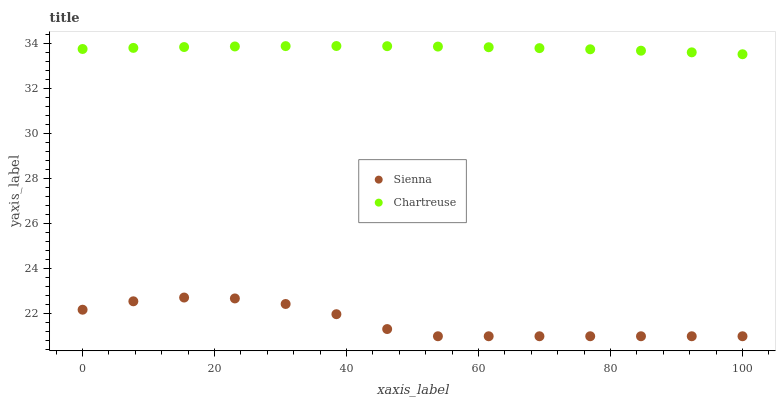Does Sienna have the minimum area under the curve?
Answer yes or no. Yes. Does Chartreuse have the maximum area under the curve?
Answer yes or no. Yes. Does Chartreuse have the minimum area under the curve?
Answer yes or no. No. Is Chartreuse the smoothest?
Answer yes or no. Yes. Is Sienna the roughest?
Answer yes or no. Yes. Is Chartreuse the roughest?
Answer yes or no. No. Does Sienna have the lowest value?
Answer yes or no. Yes. Does Chartreuse have the lowest value?
Answer yes or no. No. Does Chartreuse have the highest value?
Answer yes or no. Yes. Is Sienna less than Chartreuse?
Answer yes or no. Yes. Is Chartreuse greater than Sienna?
Answer yes or no. Yes. Does Sienna intersect Chartreuse?
Answer yes or no. No. 